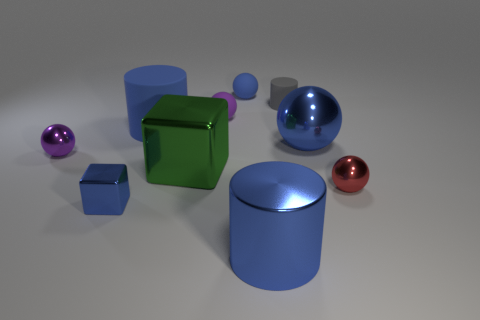Can you describe the lighting and shadows observed in the scene? The lighting in the scene is diffused, casting soft shadows that enhance the dimensionality of the objects. The shadows are consistent with an overhead light source, and they contribute to a sense of depth and position of each object in relation to the others. 